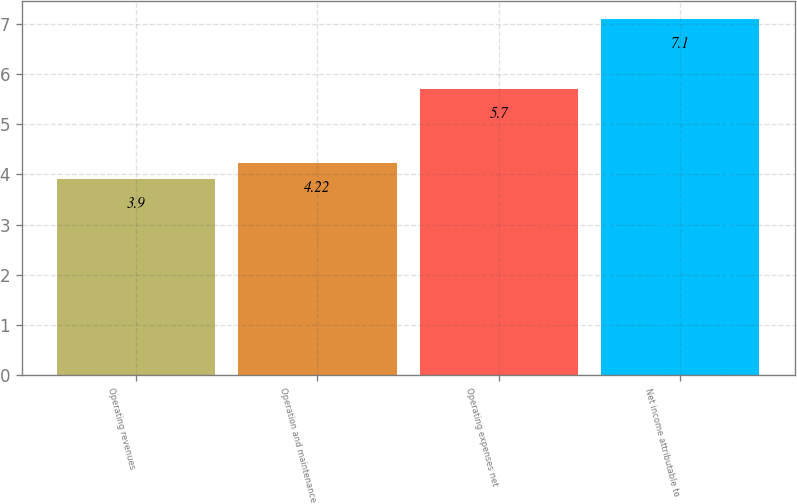Convert chart to OTSL. <chart><loc_0><loc_0><loc_500><loc_500><bar_chart><fcel>Operating revenues<fcel>Operation and maintenance<fcel>Operating expenses net<fcel>Net income attributable to<nl><fcel>3.9<fcel>4.22<fcel>5.7<fcel>7.1<nl></chart> 